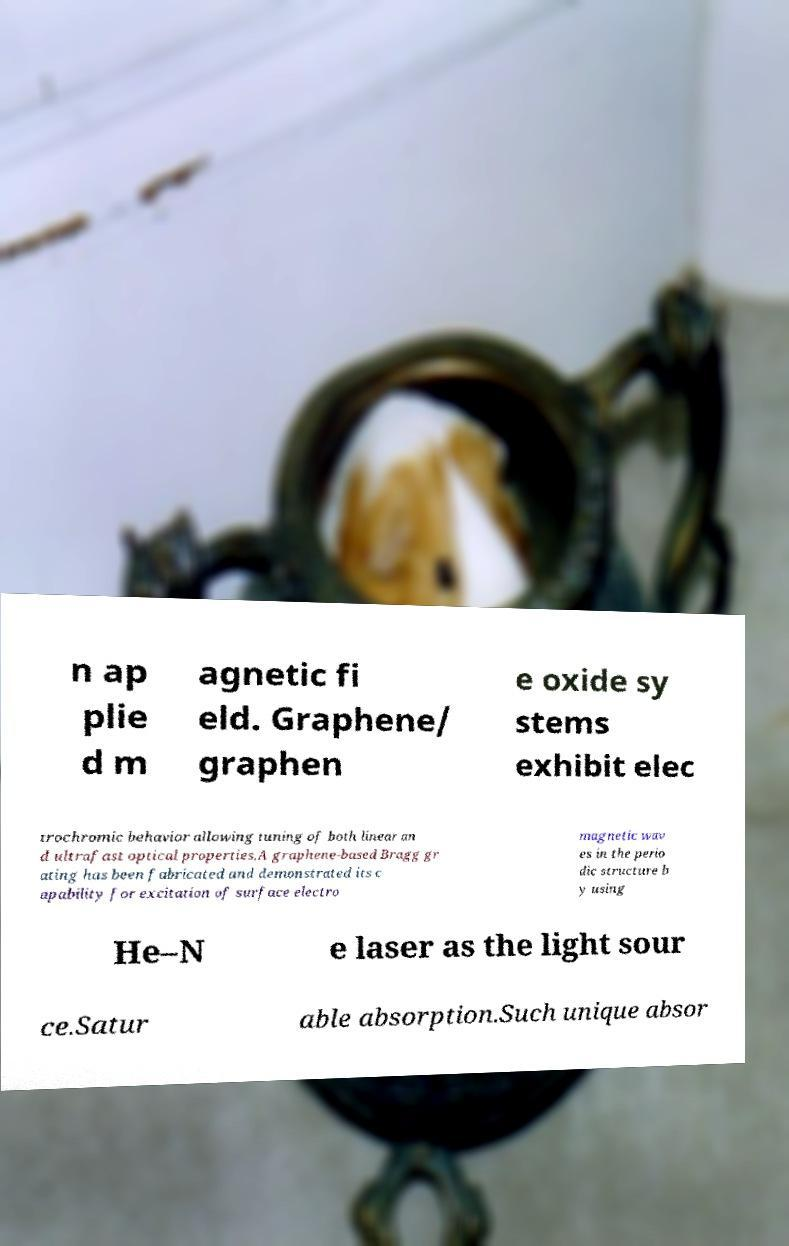What messages or text are displayed in this image? I need them in a readable, typed format. n ap plie d m agnetic fi eld. Graphene/ graphen e oxide sy stems exhibit elec trochromic behavior allowing tuning of both linear an d ultrafast optical properties.A graphene-based Bragg gr ating has been fabricated and demonstrated its c apability for excitation of surface electro magnetic wav es in the perio dic structure b y using He–N e laser as the light sour ce.Satur able absorption.Such unique absor 